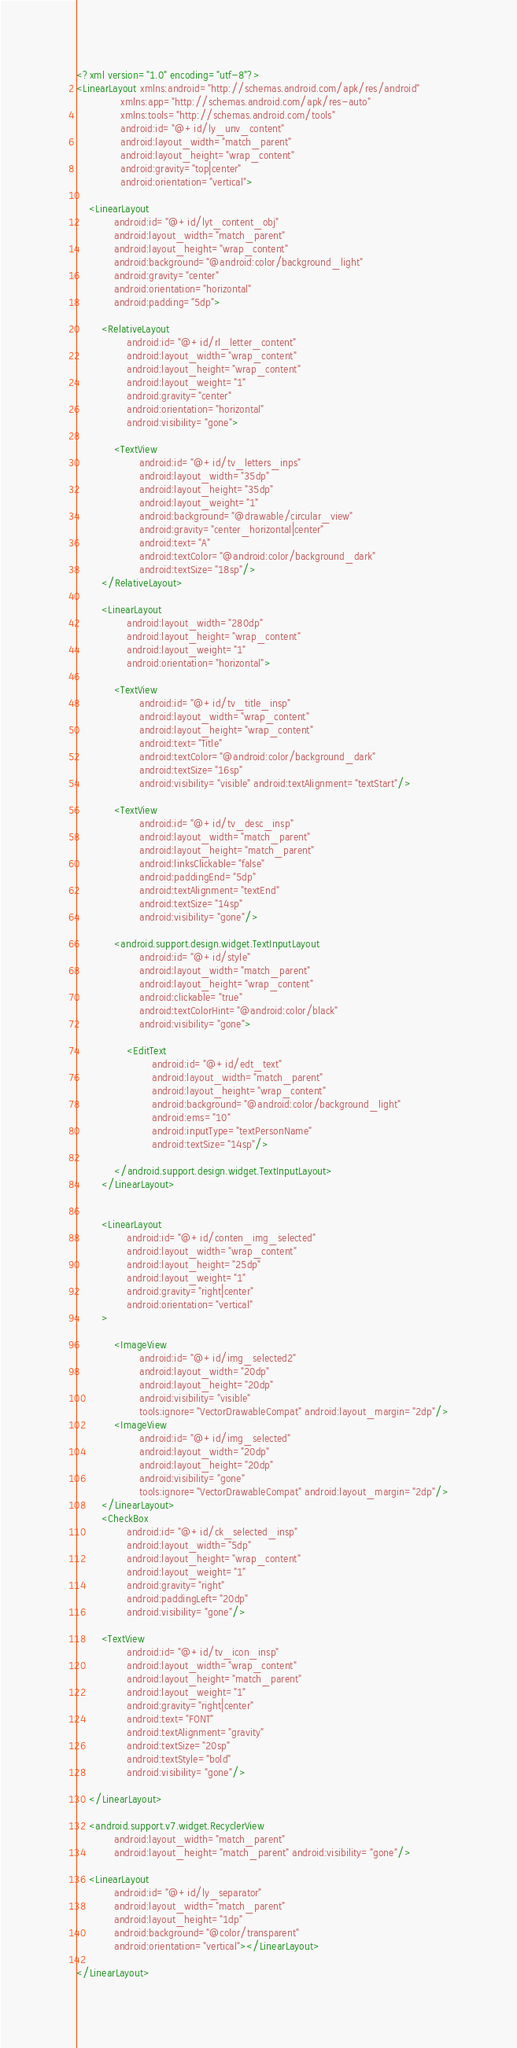Convert code to text. <code><loc_0><loc_0><loc_500><loc_500><_XML_><?xml version="1.0" encoding="utf-8"?>
<LinearLayout xmlns:android="http://schemas.android.com/apk/res/android"
              xmlns:app="http://schemas.android.com/apk/res-auto"
              xmlns:tools="http://schemas.android.com/tools"
              android:id="@+id/ly_unv_content"
              android:layout_width="match_parent"
              android:layout_height="wrap_content"
              android:gravity="top|center"
              android:orientation="vertical">

    <LinearLayout
            android:id="@+id/lyt_content_obj"
            android:layout_width="match_parent"
            android:layout_height="wrap_content"
            android:background="@android:color/background_light"
            android:gravity="center"
            android:orientation="horizontal"
            android:padding="5dp">

        <RelativeLayout
                android:id="@+id/rl_letter_content"
                android:layout_width="wrap_content"
                android:layout_height="wrap_content"
                android:layout_weight="1"
                android:gravity="center"
                android:orientation="horizontal"
                android:visibility="gone">

            <TextView
                    android:id="@+id/tv_letters_inps"
                    android:layout_width="35dp"
                    android:layout_height="35dp"
                    android:layout_weight="1"
                    android:background="@drawable/circular_view"
                    android:gravity="center_horizontal|center"
                    android:text="A"
                    android:textColor="@android:color/background_dark"
                    android:textSize="18sp"/>
        </RelativeLayout>

        <LinearLayout
                android:layout_width="280dp"
                android:layout_height="wrap_content"
                android:layout_weight="1"
                android:orientation="horizontal">

            <TextView
                    android:id="@+id/tv_title_insp"
                    android:layout_width="wrap_content"
                    android:layout_height="wrap_content"
                    android:text="Title"
                    android:textColor="@android:color/background_dark"
                    android:textSize="16sp"
                    android:visibility="visible" android:textAlignment="textStart"/>

            <TextView
                    android:id="@+id/tv_desc_insp"
                    android:layout_width="match_parent"
                    android:layout_height="match_parent"
                    android:linksClickable="false"
                    android:paddingEnd="5dp"
                    android:textAlignment="textEnd"
                    android:textSize="14sp"
                    android:visibility="gone"/>

            <android.support.design.widget.TextInputLayout
                    android:id="@+id/style"
                    android:layout_width="match_parent"
                    android:layout_height="wrap_content"
                    android:clickable="true"
                    android:textColorHint="@android:color/black"
                    android:visibility="gone">

                <EditText
                        android:id="@+id/edt_text"
                        android:layout_width="match_parent"
                        android:layout_height="wrap_content"
                        android:background="@android:color/background_light"
                        android:ems="10"
                        android:inputType="textPersonName"
                        android:textSize="14sp"/>

            </android.support.design.widget.TextInputLayout>
        </LinearLayout>


        <LinearLayout
                android:id="@+id/conten_img_selected"
                android:layout_width="wrap_content"
                android:layout_height="25dp"
                android:layout_weight="1"
                android:gravity="right|center"
                android:orientation="vertical"
        >

            <ImageView
                    android:id="@+id/img_selected2"
                    android:layout_width="20dp"
                    android:layout_height="20dp"
                    android:visibility="visible"
                    tools:ignore="VectorDrawableCompat" android:layout_margin="2dp"/>
            <ImageView
                    android:id="@+id/img_selected"
                    android:layout_width="20dp"
                    android:layout_height="20dp"
                    android:visibility="gone"
                    tools:ignore="VectorDrawableCompat" android:layout_margin="2dp"/>
        </LinearLayout>
        <CheckBox
                android:id="@+id/ck_selected_insp"
                android:layout_width="5dp"
                android:layout_height="wrap_content"
                android:layout_weight="1"
                android:gravity="right"
                android:paddingLeft="20dp"
                android:visibility="gone"/>

        <TextView
                android:id="@+id/tv_icon_insp"
                android:layout_width="wrap_content"
                android:layout_height="match_parent"
                android:layout_weight="1"
                android:gravity="right|center"
                android:text="FONT"
                android:textAlignment="gravity"
                android:textSize="20sp"
                android:textStyle="bold"
                android:visibility="gone"/>

    </LinearLayout>

    <android.support.v7.widget.RecyclerView
            android:layout_width="match_parent"
            android:layout_height="match_parent" android:visibility="gone"/>

    <LinearLayout
            android:id="@+id/ly_separator"
            android:layout_width="match_parent"
            android:layout_height="1dp"
            android:background="@color/transparent"
            android:orientation="vertical"></LinearLayout>

</LinearLayout>
</code> 